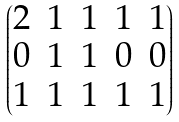<formula> <loc_0><loc_0><loc_500><loc_500>\begin{pmatrix} 2 & 1 & 1 & 1 & 1 \\ 0 & 1 & 1 & 0 & 0 \\ 1 & 1 & 1 & 1 & 1 \end{pmatrix}</formula> 